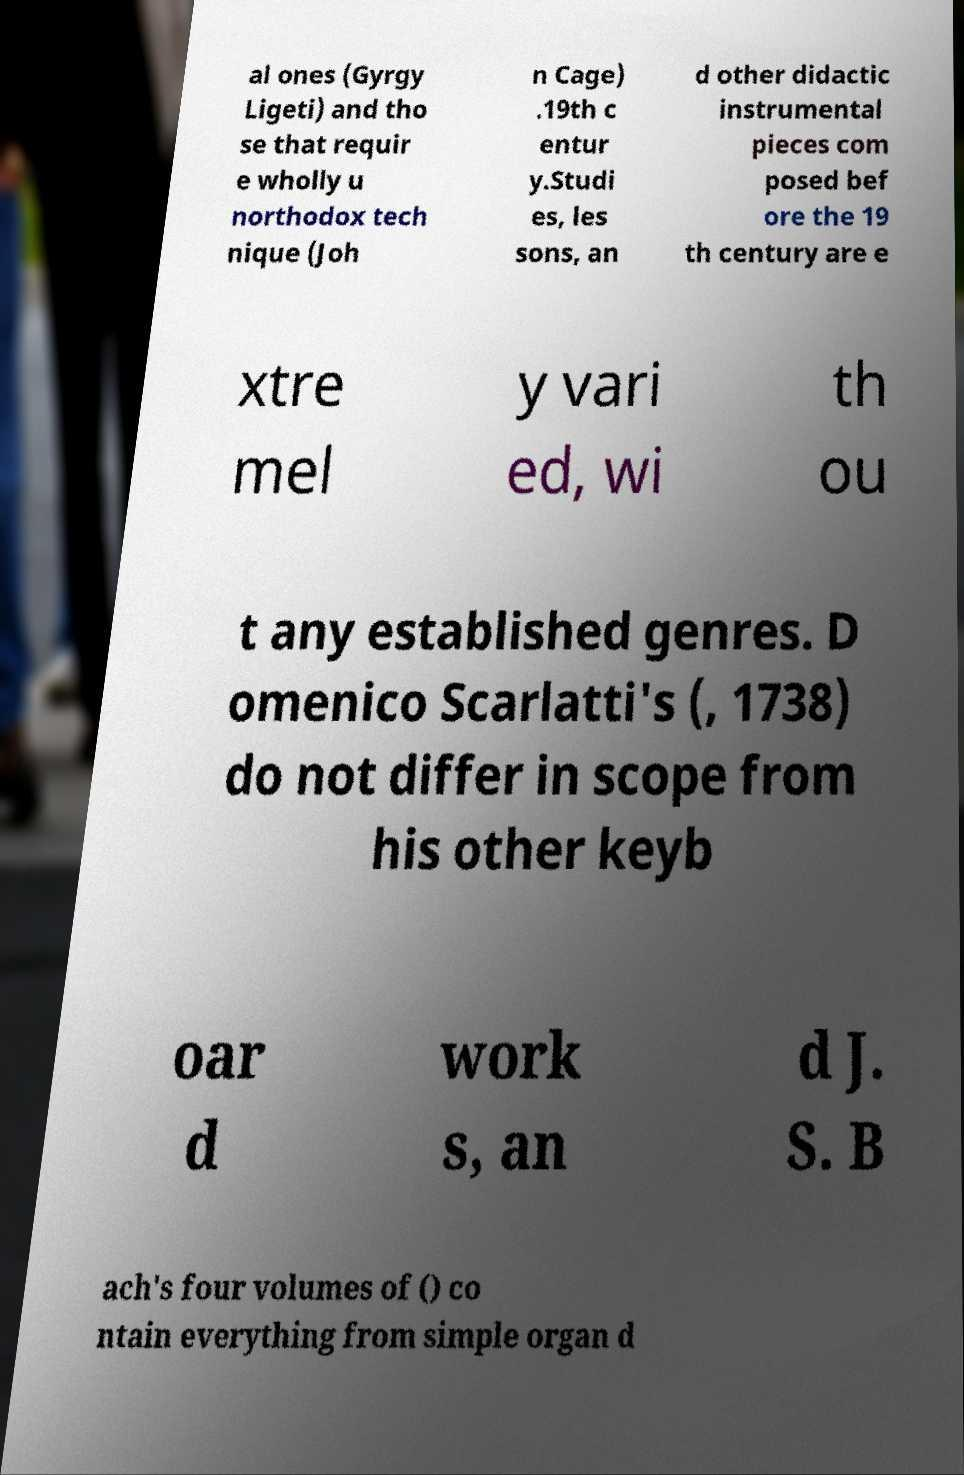For documentation purposes, I need the text within this image transcribed. Could you provide that? al ones (Gyrgy Ligeti) and tho se that requir e wholly u northodox tech nique (Joh n Cage) .19th c entur y.Studi es, les sons, an d other didactic instrumental pieces com posed bef ore the 19 th century are e xtre mel y vari ed, wi th ou t any established genres. D omenico Scarlatti's (, 1738) do not differ in scope from his other keyb oar d work s, an d J. S. B ach's four volumes of () co ntain everything from simple organ d 